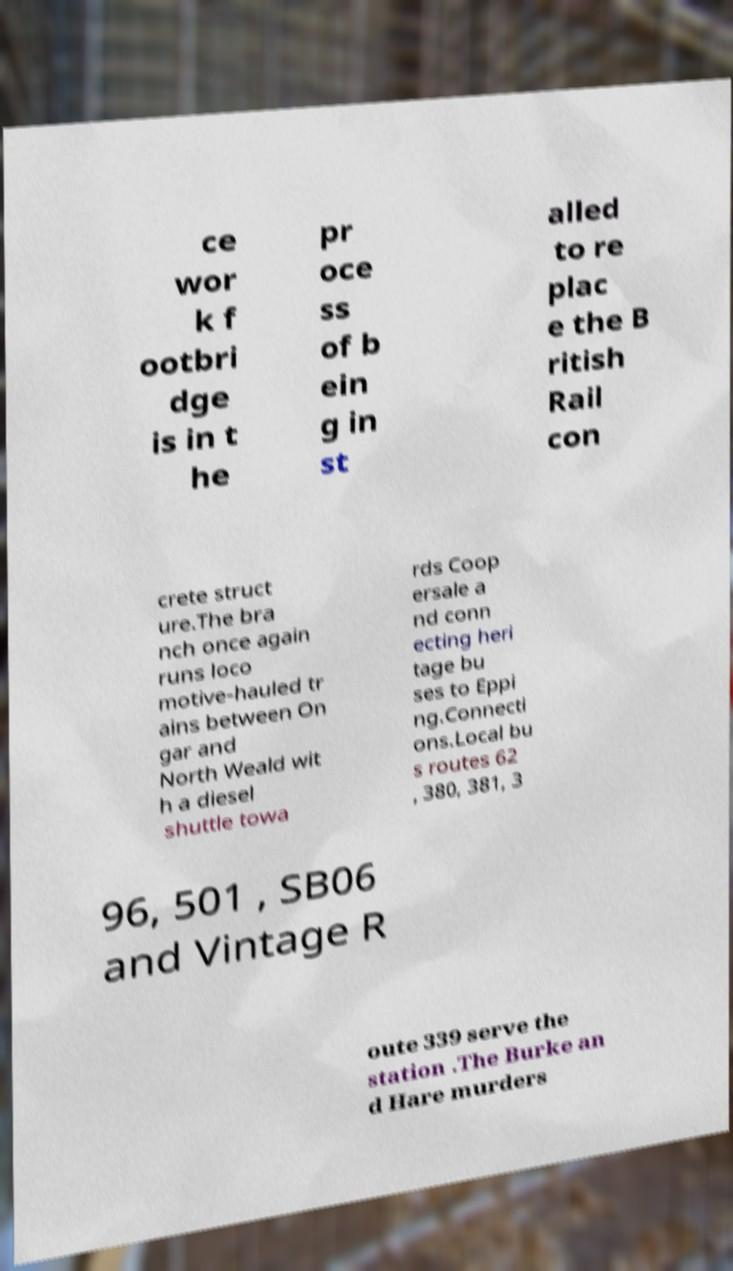Please identify and transcribe the text found in this image. ce wor k f ootbri dge is in t he pr oce ss of b ein g in st alled to re plac e the B ritish Rail con crete struct ure.The bra nch once again runs loco motive-hauled tr ains between On gar and North Weald wit h a diesel shuttle towa rds Coop ersale a nd conn ecting heri tage bu ses to Eppi ng.Connecti ons.Local bu s routes 62 , 380, 381, 3 96, 501 , SB06 and Vintage R oute 339 serve the station .The Burke an d Hare murders 